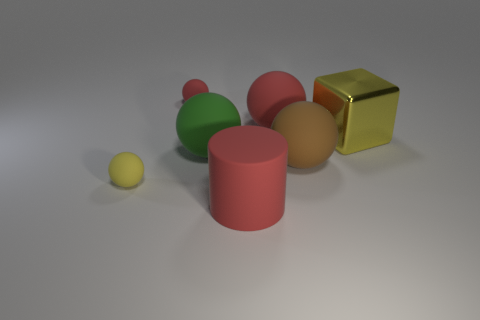Are there any other things that have the same material as the big yellow cube?
Your answer should be compact. No. What number of matte objects are behind the yellow metal thing and in front of the big yellow object?
Make the answer very short. 0. Is the number of small objects behind the brown sphere greater than the number of big cyan metal objects?
Offer a terse response. Yes. What number of metal things have the same size as the rubber cylinder?
Your response must be concise. 1. The rubber object that is the same color as the big cube is what size?
Give a very brief answer. Small. What number of large things are either red rubber cylinders or red rubber objects?
Provide a succinct answer. 2. What number of yellow shiny cylinders are there?
Offer a very short reply. 0. Is the number of green things right of the large brown rubber ball the same as the number of balls that are to the right of the big red ball?
Provide a short and direct response. No. There is a large green object; are there any yellow matte objects on the right side of it?
Offer a terse response. No. What color is the large thing right of the large brown thing?
Give a very brief answer. Yellow. 